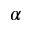Convert formula to latex. <formula><loc_0><loc_0><loc_500><loc_500>\alpha</formula> 